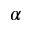Convert formula to latex. <formula><loc_0><loc_0><loc_500><loc_500>\alpha</formula> 